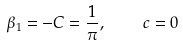Convert formula to latex. <formula><loc_0><loc_0><loc_500><loc_500>\beta _ { 1 } = - C = \frac { 1 } { \pi } , \quad c = 0</formula> 